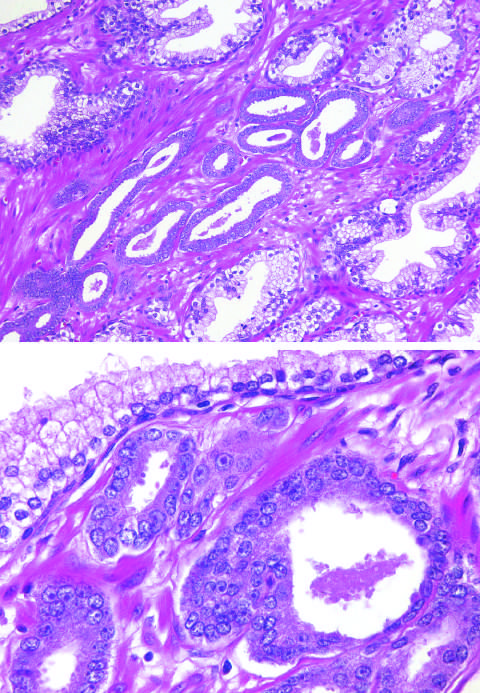what is crowded in between larger benign glands?
Answer the question using a single word or phrase. Small glands 